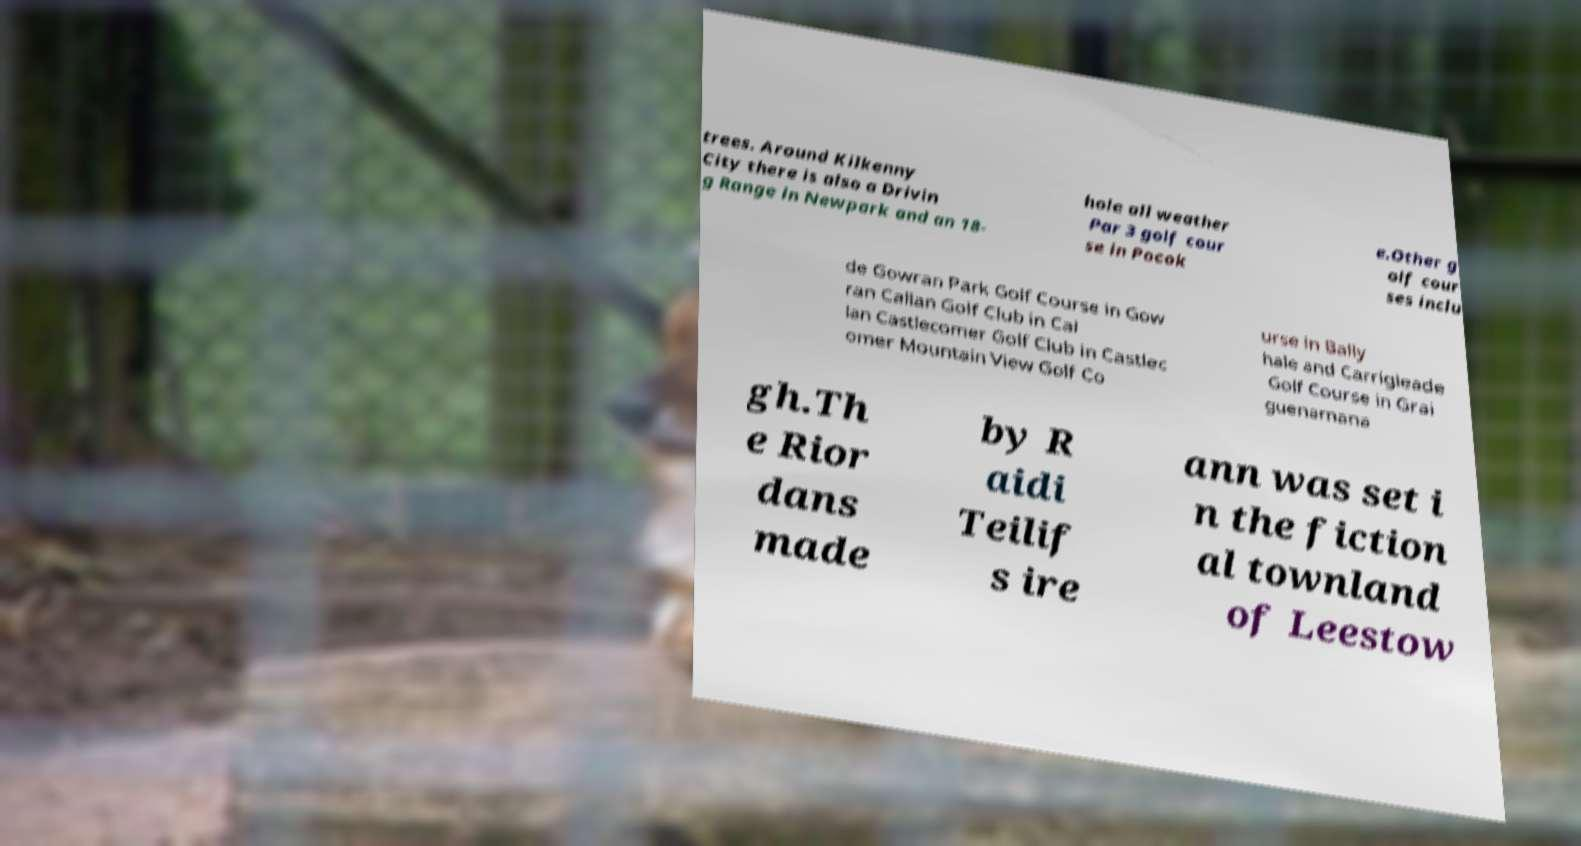Please read and relay the text visible in this image. What does it say? trees. Around Kilkenny City there is also a Drivin g Range in Newpark and an 18- hole all weather Par 3 golf cour se in Pocok e.Other g olf cour ses inclu de Gowran Park Golf Course in Gow ran Callan Golf Club in Cal lan Castlecomer Golf Club in Castlec omer Mountain View Golf Co urse in Bally hale and Carrigleade Golf Course in Grai guenamana gh.Th e Rior dans made by R aidi Teilif s ire ann was set i n the fiction al townland of Leestow 